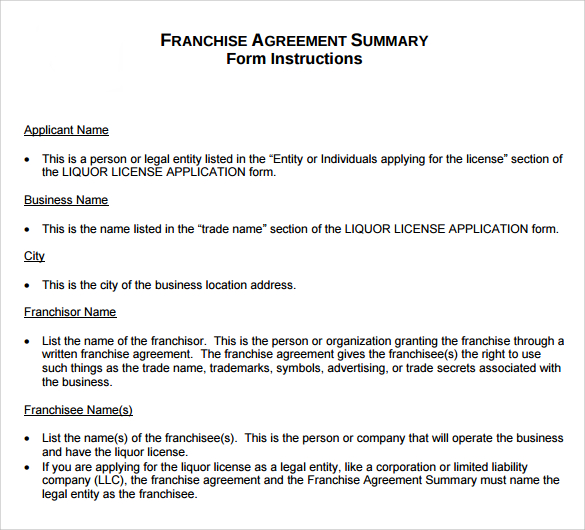Can you explain why it's necessary for corporate entities to be named in the Franchise Agreement Summary for a liquor license? It's important for corporate entities to be named in the Franchise Agreement Summary when applying for a liquor license to ensure legal and financial accountability. Since the operation of a franchise involves numerous regulations, especially relating to liquor sales, having a clearly identified legal entity helps in maintaining clarity about who is responsible for adhering to the legal standards and obligations. This specificity aids in governance and simplifies legal proceedings or compliance checking by regulatory bodies. 